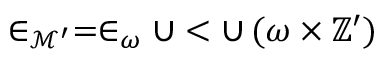<formula> <loc_0><loc_0><loc_500><loc_500>\in _ { { \mathcal { M } } ^ { \prime } } = \in _ { \omega } \cup < \cup \, ( \omega \times \mathbb { Z } ^ { \prime } )</formula> 